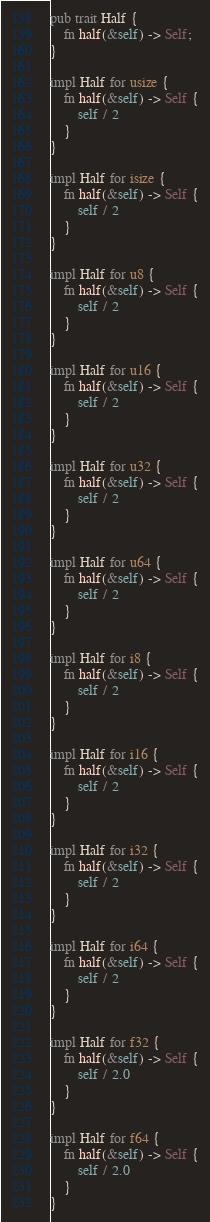Convert code to text. <code><loc_0><loc_0><loc_500><loc_500><_Rust_>pub trait Half {
    fn half(&self) -> Self;
}

impl Half for usize {
    fn half(&self) -> Self {
        self / 2
    }
}

impl Half for isize {
    fn half(&self) -> Self {
        self / 2
    }
}

impl Half for u8 {
    fn half(&self) -> Self {
        self / 2
    }
}

impl Half for u16 {
    fn half(&self) -> Self {
        self / 2
    }
}

impl Half for u32 {
    fn half(&self) -> Self {
        self / 2
    }
}

impl Half for u64 {
    fn half(&self) -> Self {
        self / 2
    }
}

impl Half for i8 {
    fn half(&self) -> Self {
        self / 2
    }
}

impl Half for i16 {
    fn half(&self) -> Self {
        self / 2
    }
}

impl Half for i32 {
    fn half(&self) -> Self {
        self / 2
    }
}

impl Half for i64 {
    fn half(&self) -> Self {
        self / 2
    }
}

impl Half for f32 {
    fn half(&self) -> Self {
        self / 2.0
    }
}

impl Half for f64 {
    fn half(&self) -> Self {
        self / 2.0
    }
}
</code> 